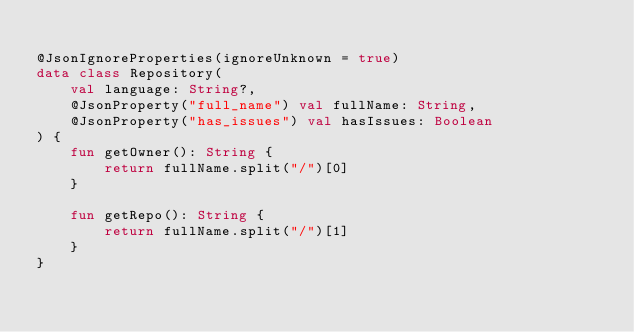Convert code to text. <code><loc_0><loc_0><loc_500><loc_500><_Kotlin_>
@JsonIgnoreProperties(ignoreUnknown = true)
data class Repository(
    val language: String?,
    @JsonProperty("full_name") val fullName: String,
    @JsonProperty("has_issues") val hasIssues: Boolean
) {
    fun getOwner(): String {
        return fullName.split("/")[0]
    }

    fun getRepo(): String {
        return fullName.split("/")[1]
    }
}
</code> 